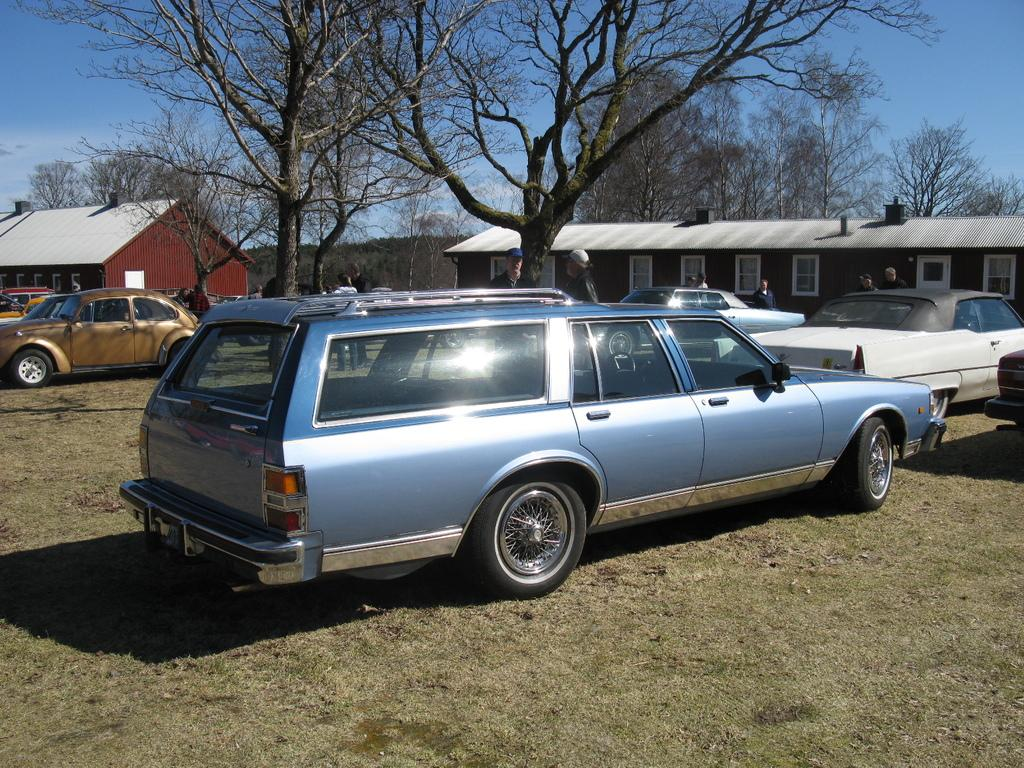What type of structures can be seen in the image? There are houses in the image. What type of vegetation is present in the image? There are trees and grass in the image. Are there any living beings in the image? Yes, there are people in the image. What else can be seen in the image besides houses, trees, and grass? There are vehicles in the image. What is visible in the background of the image? The sky is visible in the image. What else can be found in the image? There are objects in the image. How is the land covered in the image? The land is covered with grass. Can you see the paint drying on the houses in the image? There is no mention of paint or drying paint in the image, so we cannot answer this question. Are there any knots visible in the image? There is no mention of knots or any objects that would have knots in the image, so we cannot answer this question. 